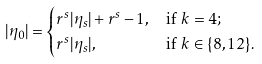Convert formula to latex. <formula><loc_0><loc_0><loc_500><loc_500>| \eta _ { 0 } | & = \begin{cases} r ^ { s } | \eta _ { s } | + r ^ { s } - 1 , & \text {if $k=4$} ; \\ r ^ { s } | \eta _ { s } | , & \text {if $k\in\{8,12\}$} . \end{cases}</formula> 